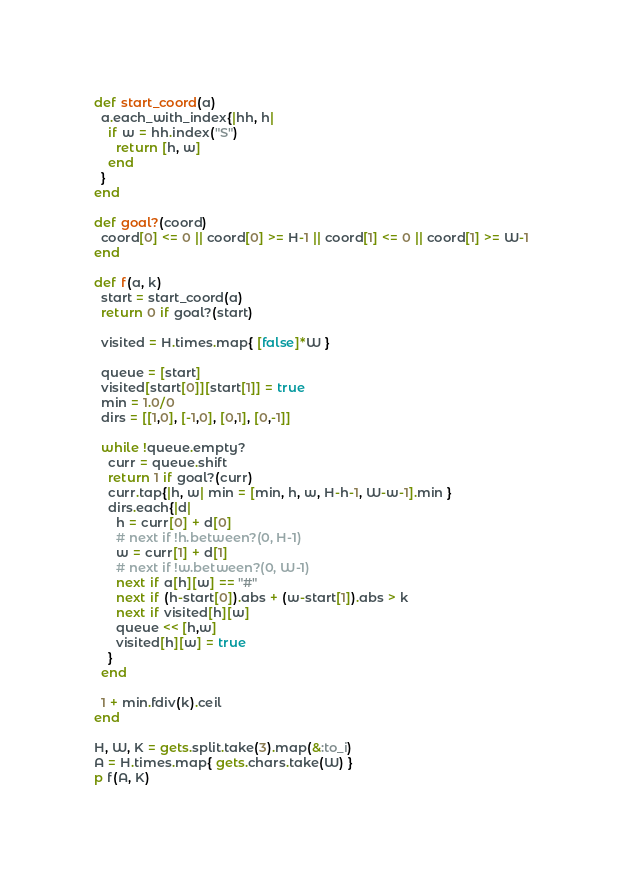Convert code to text. <code><loc_0><loc_0><loc_500><loc_500><_Ruby_>def start_coord(a)
  a.each_with_index{|hh, h|
    if w = hh.index("S")
      return [h, w]
    end
  }
end

def goal?(coord)
  coord[0] <= 0 || coord[0] >= H-1 || coord[1] <= 0 || coord[1] >= W-1
end

def f(a, k)
  start = start_coord(a)
  return 0 if goal?(start)

  visited = H.times.map{ [false]*W }

  queue = [start]
  visited[start[0]][start[1]] = true
  min = 1.0/0
  dirs = [[1,0], [-1,0], [0,1], [0,-1]]

  while !queue.empty?
    curr = queue.shift
    return 1 if goal?(curr)
    curr.tap{|h, w| min = [min, h, w, H-h-1, W-w-1].min }
    dirs.each{|d|
      h = curr[0] + d[0]
      # next if !h.between?(0, H-1)
      w = curr[1] + d[1]
      # next if !w.between?(0, W-1)
      next if a[h][w] == "#"
      next if (h-start[0]).abs + (w-start[1]).abs > k
      next if visited[h][w]
      queue << [h,w]
      visited[h][w] = true
    }
  end

  1 + min.fdiv(k).ceil
end

H, W, K = gets.split.take(3).map(&:to_i)
A = H.times.map{ gets.chars.take(W) }
p f(A, K)
</code> 